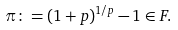Convert formula to latex. <formula><loc_0><loc_0><loc_500><loc_500>\pi \colon = ( 1 + p ) ^ { 1 / p } - 1 \in F .</formula> 